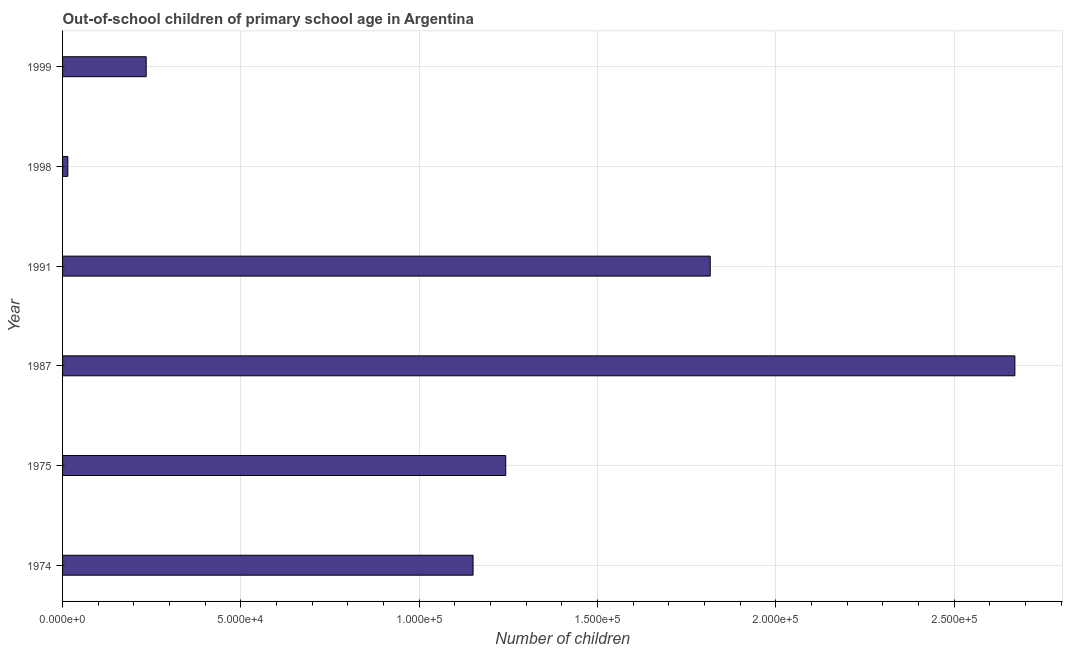Does the graph contain any zero values?
Keep it short and to the point. No. Does the graph contain grids?
Your answer should be compact. Yes. What is the title of the graph?
Offer a terse response. Out-of-school children of primary school age in Argentina. What is the label or title of the X-axis?
Provide a succinct answer. Number of children. What is the number of out-of-school children in 1999?
Your answer should be compact. 2.34e+04. Across all years, what is the maximum number of out-of-school children?
Your answer should be very brief. 2.67e+05. Across all years, what is the minimum number of out-of-school children?
Your answer should be compact. 1475. In which year was the number of out-of-school children maximum?
Make the answer very short. 1987. In which year was the number of out-of-school children minimum?
Provide a succinct answer. 1998. What is the sum of the number of out-of-school children?
Your response must be concise. 7.13e+05. What is the difference between the number of out-of-school children in 1987 and 1999?
Provide a succinct answer. 2.44e+05. What is the average number of out-of-school children per year?
Provide a short and direct response. 1.19e+05. What is the median number of out-of-school children?
Provide a succinct answer. 1.20e+05. What is the ratio of the number of out-of-school children in 1974 to that in 1991?
Make the answer very short. 0.63. Is the difference between the number of out-of-school children in 1987 and 1999 greater than the difference between any two years?
Your answer should be very brief. No. What is the difference between the highest and the second highest number of out-of-school children?
Provide a succinct answer. 8.54e+04. What is the difference between the highest and the lowest number of out-of-school children?
Provide a succinct answer. 2.66e+05. How many years are there in the graph?
Make the answer very short. 6. What is the difference between two consecutive major ticks on the X-axis?
Your answer should be compact. 5.00e+04. What is the Number of children in 1974?
Ensure brevity in your answer.  1.15e+05. What is the Number of children of 1975?
Make the answer very short. 1.24e+05. What is the Number of children in 1987?
Provide a succinct answer. 2.67e+05. What is the Number of children in 1991?
Provide a short and direct response. 1.82e+05. What is the Number of children of 1998?
Offer a very short reply. 1475. What is the Number of children of 1999?
Make the answer very short. 2.34e+04. What is the difference between the Number of children in 1974 and 1975?
Offer a very short reply. -9156. What is the difference between the Number of children in 1974 and 1987?
Give a very brief answer. -1.52e+05. What is the difference between the Number of children in 1974 and 1991?
Offer a terse response. -6.65e+04. What is the difference between the Number of children in 1974 and 1998?
Your response must be concise. 1.14e+05. What is the difference between the Number of children in 1974 and 1999?
Make the answer very short. 9.16e+04. What is the difference between the Number of children in 1975 and 1987?
Your answer should be very brief. -1.43e+05. What is the difference between the Number of children in 1975 and 1991?
Offer a very short reply. -5.73e+04. What is the difference between the Number of children in 1975 and 1998?
Keep it short and to the point. 1.23e+05. What is the difference between the Number of children in 1975 and 1999?
Your answer should be very brief. 1.01e+05. What is the difference between the Number of children in 1987 and 1991?
Provide a short and direct response. 8.54e+04. What is the difference between the Number of children in 1987 and 1998?
Your answer should be very brief. 2.66e+05. What is the difference between the Number of children in 1987 and 1999?
Offer a terse response. 2.44e+05. What is the difference between the Number of children in 1991 and 1998?
Offer a very short reply. 1.80e+05. What is the difference between the Number of children in 1991 and 1999?
Your answer should be very brief. 1.58e+05. What is the difference between the Number of children in 1998 and 1999?
Make the answer very short. -2.20e+04. What is the ratio of the Number of children in 1974 to that in 1975?
Your answer should be very brief. 0.93. What is the ratio of the Number of children in 1974 to that in 1987?
Make the answer very short. 0.43. What is the ratio of the Number of children in 1974 to that in 1991?
Offer a very short reply. 0.63. What is the ratio of the Number of children in 1974 to that in 1998?
Ensure brevity in your answer.  78.03. What is the ratio of the Number of children in 1974 to that in 1999?
Offer a very short reply. 4.91. What is the ratio of the Number of children in 1975 to that in 1987?
Give a very brief answer. 0.47. What is the ratio of the Number of children in 1975 to that in 1991?
Make the answer very short. 0.68. What is the ratio of the Number of children in 1975 to that in 1998?
Provide a short and direct response. 84.23. What is the ratio of the Number of children in 1975 to that in 1999?
Provide a short and direct response. 5.3. What is the ratio of the Number of children in 1987 to that in 1991?
Provide a succinct answer. 1.47. What is the ratio of the Number of children in 1987 to that in 1998?
Make the answer very short. 181.01. What is the ratio of the Number of children in 1987 to that in 1999?
Provide a succinct answer. 11.39. What is the ratio of the Number of children in 1991 to that in 1998?
Keep it short and to the point. 123.1. What is the ratio of the Number of children in 1991 to that in 1999?
Provide a short and direct response. 7.74. What is the ratio of the Number of children in 1998 to that in 1999?
Keep it short and to the point. 0.06. 